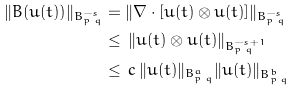Convert formula to latex. <formula><loc_0><loc_0><loc_500><loc_500>\| B ( u ( t ) ) \| _ { B ^ { - s } _ { p \, q } } & = \| \nabla \cdot [ u ( t ) \otimes u ( t ) ] \| _ { B ^ { - s } _ { p \, q } } \\ & \leq \, \| u ( t ) \otimes u ( t ) \| _ { B ^ { - s + 1 } _ { p \, q } } \\ & \leq \, c \, \| u ( t ) \| _ { B ^ { a } _ { p \, q } } \| u ( t ) \| _ { B ^ { b } _ { p \, q } } \\</formula> 